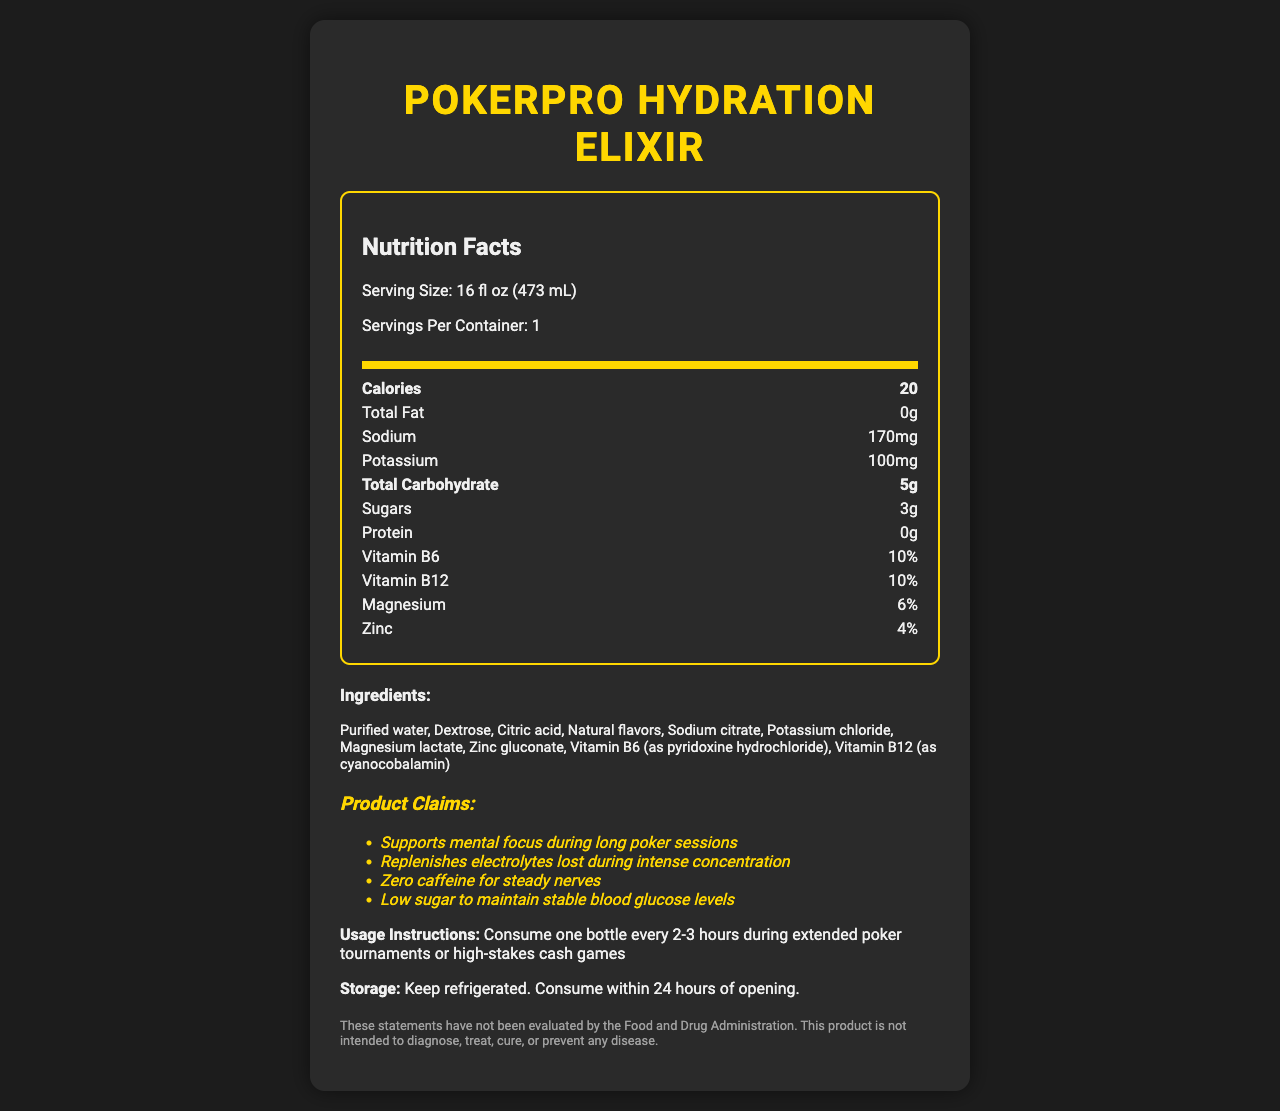who is the product intended for? The product name "PokerPro Hydration Elixir" and claims such as "Supports mental focus during long poker sessions" indicate that it is intended for poker players.
Answer: Poker players what is the serving size? The document states the serving size as "16 fl oz (473 mL)".
Answer: 16 fl oz (473 mL) how many calories does each serving contain? Under the "Calories" section, it is mentioned that each serving contains 20 calories.
Answer: 20 what minerals are included in the beverage? These minerals are listed in the nutrition facts part of the document.
Answer: Sodium, Potassium, Magnesium, Zinc how much sugar is in each serving? The "Sugars" section in the nutrition facts shows that each serving contains 3 grams of sugar.
Answer: 3g How often should you consume the beverage during long poker sessions? A. Every hour B. Every 2-3 hours C. Every 4-5 hours D. Once a day The usage instructions specify "Consume one bottle every 2-3 hours during extended poker tournaments or high-stakes cash games".
Answer: B which vitamin has the highest percentage of daily value? A. Vitamin B6 B. Vitamin B12 C. Magnesium D. Zinc Vitamin B6 and Vitamin B12 both have 10%, but Vitamin B6 is listed first, typically indicating slight precedence.
Answer: A is this product caffeine-free? One of the claims is "Zero caffeine for steady nerves," which indicates the product is caffeine-free.
Answer: Yes does the product have any protein? The nutrition facts state that the protein content is 0g.
Answer: No are there any allergens associated with this product? The allergen information specifies "Produced in a facility that processes milk and soy".
Answer: Yes summarize the document in one sentence. The document includes information on serving size, calories, minerals, and vitamins, along with product claims, usage instructions, and allergen information.
Answer: The document provides comprehensive nutrition facts, usage instructions, ingredient details, and claims for the PokerPro Hydration Elixir, an electrolyte-enhanced hydration beverage for poker players. what are the main ingredients in the beverage? The ingredients list starts with "Purified water, Dextrose, Citric acid," indicating these are the main ingredients.
Answer: Purified water, Dextrose, Citric acid where should you store the beverage after opening? The storage instructions specify "Keep refrigerated. Consume within 24 hours of opening."
Answer: In the refrigerator is this product intended to diagnose, treat, cure, or prevent any disease? The disclaimer explicitly states, "This product is not intended to diagnose, treat, cure, or prevent any disease."
Answer: No how much potassium does each serving contain? The nutrition facts list potassium content as 100 mg per serving.
Answer: 100 mg can the potential effects of the product be verified by the FDA? The disclaimer indicates that "These statements have not been evaluated by the Food and Drug Administration."
Answer: No what percentage of daily value does vitamin B6 provide? The nutrition facts indicate that Vitamin B6 provides 10% of the daily value.
Answer: 10% how much total fat is in each serving? The total fat content per serving is listed as 0 grams.
Answer: 0g What are the user-oriented claims listed for the product? These claims are explicitly listed under the "claims" section.
Answer: Supports mental focus during long poker sessions, Replenishes electrolytes lost during intense concentration, Zero caffeine for steady nerves, Low sugar to maintain stable blood glucose levels who manufactures the PokerPro Hydration Elixir? The document does not include information about the manufacturer of the product.
Answer: Cannot be determined 